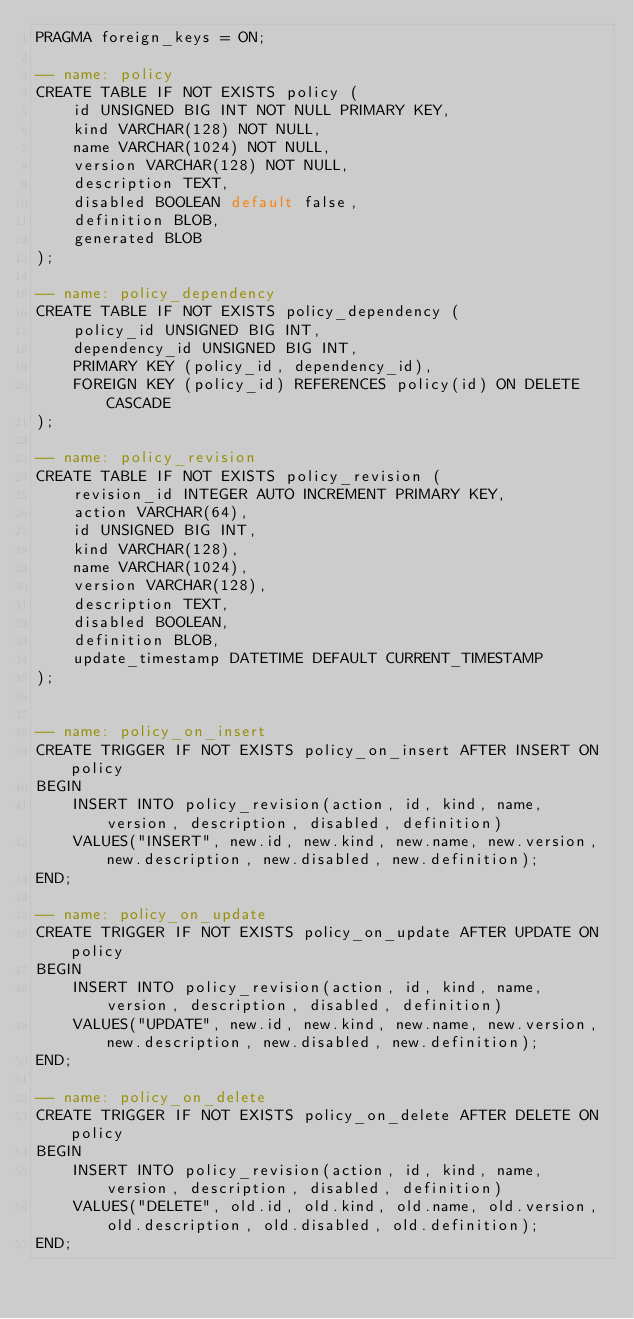Convert code to text. <code><loc_0><loc_0><loc_500><loc_500><_SQL_>PRAGMA foreign_keys = ON;

-- name: policy
CREATE TABLE IF NOT EXISTS policy (
    id UNSIGNED BIG INT NOT NULL PRIMARY KEY, 
    kind VARCHAR(128) NOT NULL,
    name VARCHAR(1024) NOT NULL,
    version VARCHAR(128) NOT NULL,
    description TEXT,
    disabled BOOLEAN default false,
    definition BLOB,
    generated BLOB
);

-- name: policy_dependency
CREATE TABLE IF NOT EXISTS policy_dependency (
    policy_id UNSIGNED BIG INT,
    dependency_id UNSIGNED BIG INT,
    PRIMARY KEY (policy_id, dependency_id),
    FOREIGN KEY (policy_id) REFERENCES policy(id) ON DELETE CASCADE
);

-- name: policy_revision
CREATE TABLE IF NOT EXISTS policy_revision (
    revision_id INTEGER AUTO INCREMENT PRIMARY KEY,
    action VARCHAR(64),
    id UNSIGNED BIG INT,
    kind VARCHAR(128),
    name VARCHAR(1024),
    version VARCHAR(128),
    description TEXT,
    disabled BOOLEAN, 
    definition BLOB,
    update_timestamp DATETIME DEFAULT CURRENT_TIMESTAMP
);


-- name: policy_on_insert
CREATE TRIGGER IF NOT EXISTS policy_on_insert AFTER INSERT ON policy 
BEGIN
    INSERT INTO policy_revision(action, id, kind, name, version, description, disabled, definition)
    VALUES("INSERT", new.id, new.kind, new.name, new.version, new.description, new.disabled, new.definition);
END;

-- name: policy_on_update
CREATE TRIGGER IF NOT EXISTS policy_on_update AFTER UPDATE ON policy 
BEGIN
    INSERT INTO policy_revision(action, id, kind, name, version, description, disabled, definition)
    VALUES("UPDATE", new.id, new.kind, new.name, new.version, new.description, new.disabled, new.definition);
END;

-- name: policy_on_delete
CREATE TRIGGER IF NOT EXISTS policy_on_delete AFTER DELETE ON policy 
BEGIN
    INSERT INTO policy_revision(action, id, kind, name, version, description, disabled, definition)
    VALUES("DELETE", old.id, old.kind, old.name, old.version, old.description, old.disabled, old.definition);
END;
</code> 